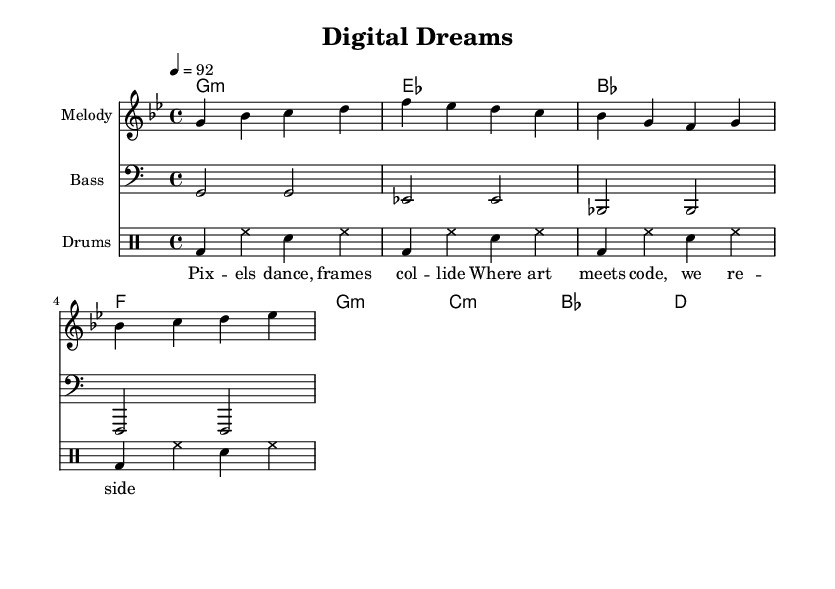What is the key signature of this music? The key signature indicates the notes to be played, and in this sheet music, it is set to G minor, as indicated by the 'g' after the \key directive.
Answer: G minor What is the time signature of this music? The time signature appears at the start of the sheet music and is indicated as 4/4, meaning there are four beats in each measure.
Answer: 4/4 What is the tempo marking for this piece? The tempo marking is given as 4 = 92, indicating that there are 92 beats per minute in the performance of the piece.
Answer: 92 What is the name of the piece? The header at the top of the sheet music states the title as "Digital Dreams."
Answer: Digital Dreams What types of expressive elements are present in this hip-hop piece? In hip-hop music, especially in this piece, elements like the urban beats, rhythmic flow in the melody, and the interaction between technology and art in the lyrics play a significant role.
Answer: Urban beats What do the lyrics suggest about the relationship between technology and art? The lyrics describe a blending of art and technology, as seen in the phrase "Where art meets code," indicating a collaborative relationship between these two fields.
Answer: Art meets code 